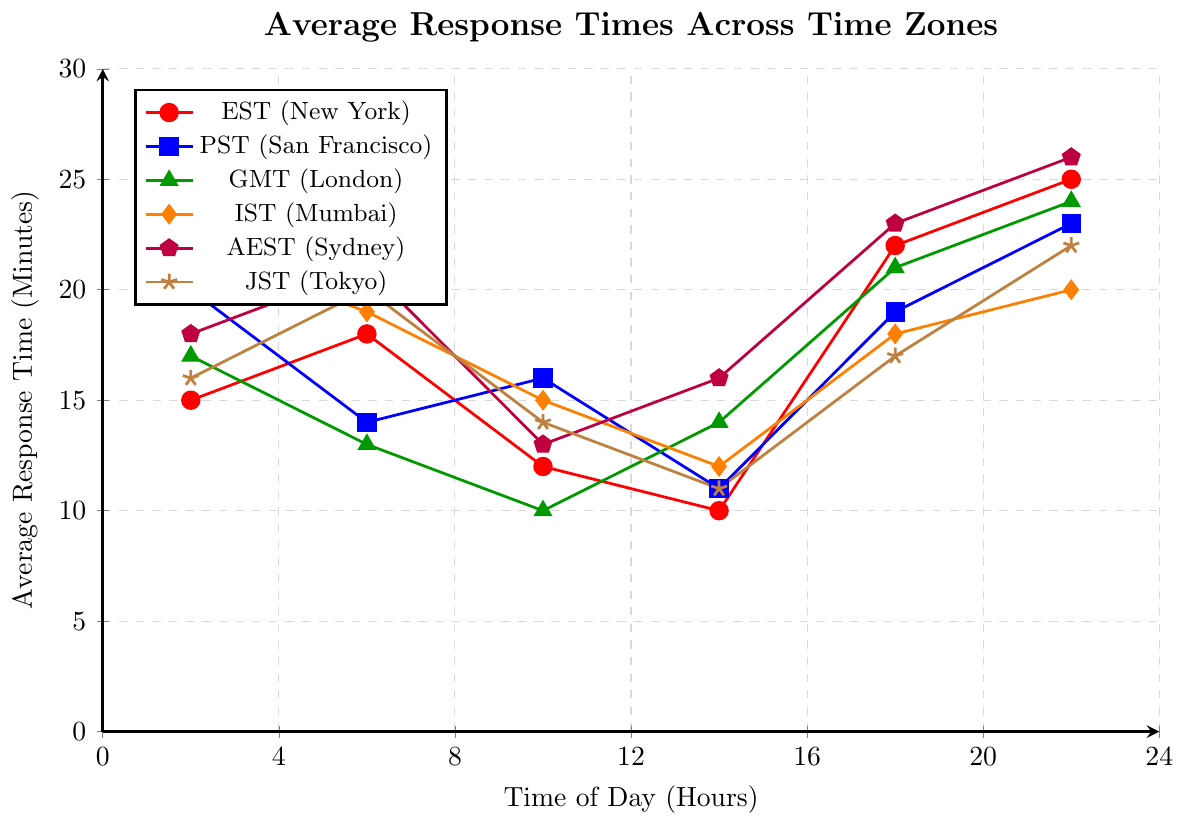What time zone has the highest response time in the 20-24 hour period? To determine this, examine the response time at the 20-24 hour mark for each time zone. The highest value is from AEST (Sydney) with a value of 26 minutes.
Answer: AEST (Sydney) During which time period does GMT (London) have the lowest response time? To find the lowest response time for GMT (London), look at all values corresponding to GMT. The lowest value is 10 minutes, which occurs in the 8-12 hour period.
Answer: 8-12 Hours What is the difference in response time between PST (San Francisco) and EST (New York) in the 0-4 hour period? Subtract the response time of EST from PST in the 0-4 hour period. PST (San Francisco) has 20 minutes and EST (New York) has 15 minutes. Therefore, 20 - 15 = 5 minutes.
Answer: 5 minutes Which time zone shows the most consistent (least variable) response times throughout the 24-hour period? To determine consistency, look at the range and variability of response times for each time zone. IST (Mumbai) appears most consistent, with values relatively close together from 12 to 22 minutes.
Answer: IST (Mumbai) What is the average response time for JST (Tokyo) across all time intervals? Add all response times for JST (Tokyo): 16 + 20 + 14 + 11 + 17 + 22 = 100. Now, divide by the number of intervals (6): 100 / 6 ≈ 16.67 minutes.
Answer: 16.67 minutes Which time zone has the lowest response time during the 12-16 hour period? Look at the response times of each time zone during the 12-16 hour period. The lowest value is 10 minutes by EST (New York).
Answer: EST (New York) How much higher is the longest response time for AEST (Sydney) compared to its shortest response time? Identify the maximum and minimum response times for AEST (Sydney). The longest is 26 minutes in the 20-24 hour period and the shortest is 13 minutes in the 8-12 hour period. The difference is 26 - 13 = 13 minutes.
Answer: 13 minutes If we combine the lowest response times across all time zones, what is the total? Identify the lowest response times for each time zone and sum them up: EST (10), PST (11), GMT (10), IST (12), AEST (13), JST (11). Total: 10 + 11 + 10 + 12 + 13 + 11 = 67 minutes.
Answer: 67 minutes 